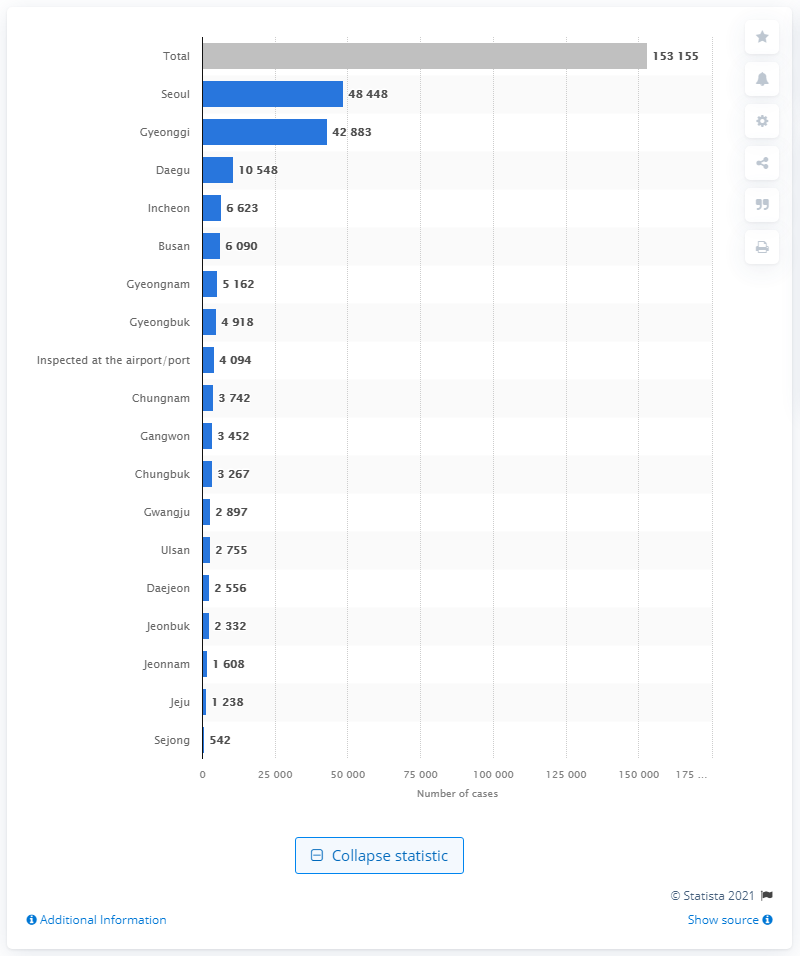Indicate a few pertinent items in this graphic. As of June 24, 2021, a total of 153,155 confirmed cases of the COVID-19 pandemic were reported worldwide. 